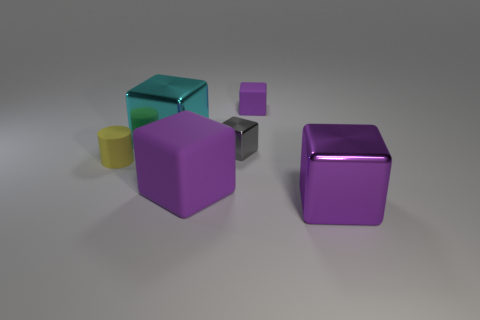How many small blocks are there?
Your answer should be compact. 2. Does the large matte object have the same color as the tiny matte cube?
Provide a short and direct response. Yes. There is a object that is on the left side of the big matte thing and in front of the gray object; what color is it?
Provide a short and direct response. Yellow. Are there any big metal things on the left side of the tiny gray metal object?
Make the answer very short. Yes. There is a purple object behind the small gray object; how many small rubber objects are in front of it?
Make the answer very short. 1. What is the size of the cylinder that is the same material as the tiny purple block?
Offer a very short reply. Small. What is the size of the gray metallic block?
Ensure brevity in your answer.  Small. Does the tiny yellow object have the same material as the tiny gray block?
Give a very brief answer. No. How many cubes are large yellow metal objects or small gray metallic objects?
Your answer should be compact. 1. What is the color of the tiny cube that is in front of the purple rubber object behind the big purple rubber object?
Ensure brevity in your answer.  Gray. 